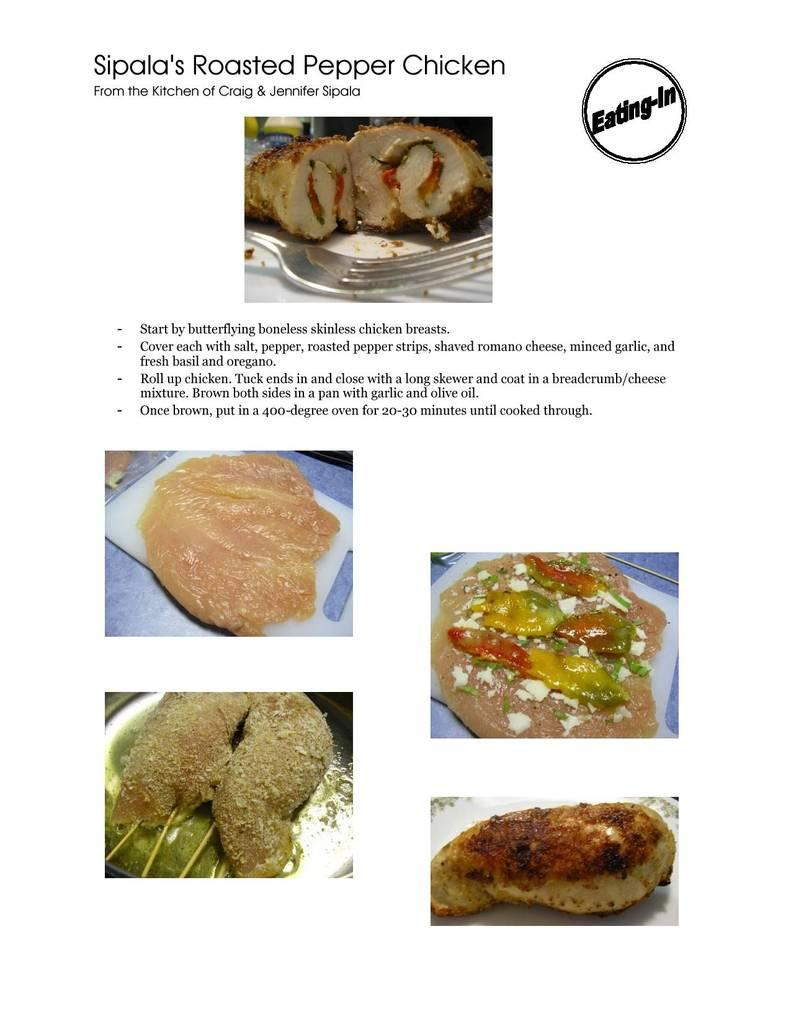What is the main subject of the poster in the image? The main subject of the poster in the image is four images of food items. What color is the text on the poster? The text on the poster is black in color. What is the background color of the poster? The background color of the poster is white. How many tickets can be seen in the image? There are no tickets present in the image. Is there a rifle depicted in the image? There is no rifle present in the image. 